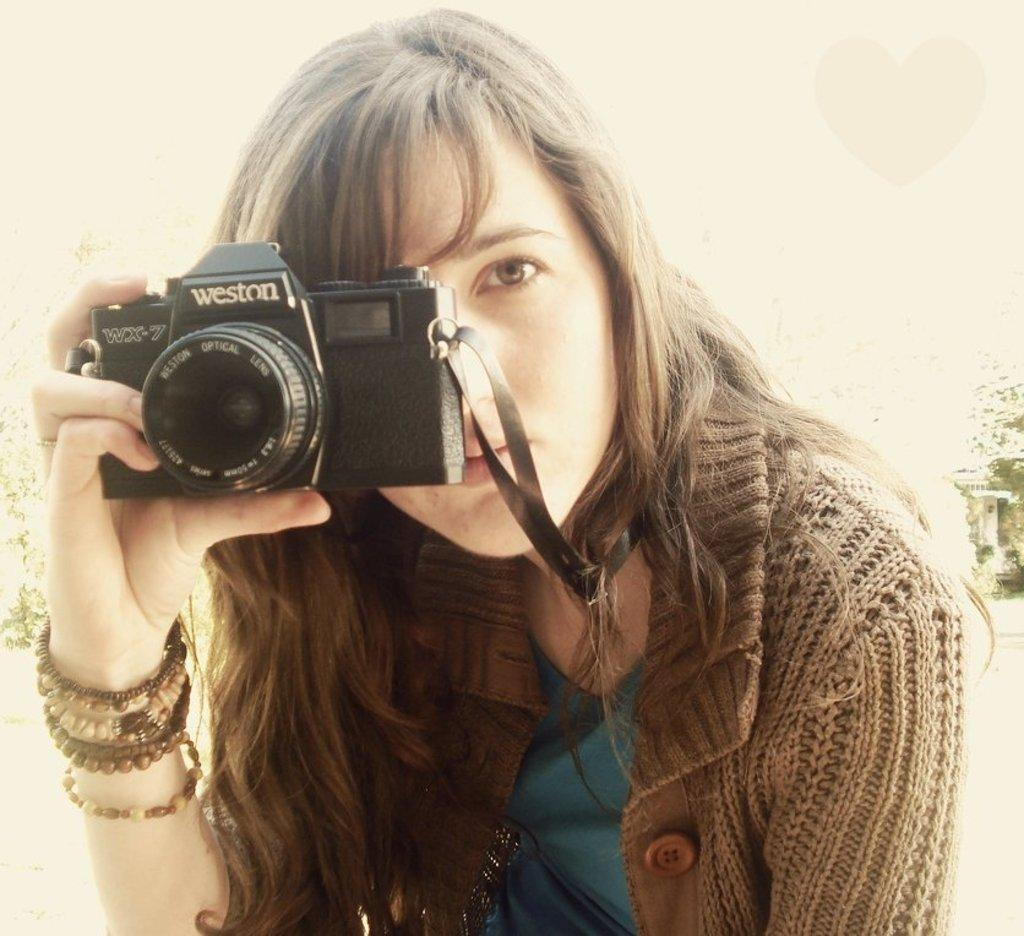Who is the main subject in the image? There is a woman in the image. What is the woman holding in the image? The woman is holding a camera. What type of haircut does the woman have in the image? There is no information about the woman's haircut in the image. What kind of stem can be seen growing from the camera in the image? There is no stem present on the camera in the image. 